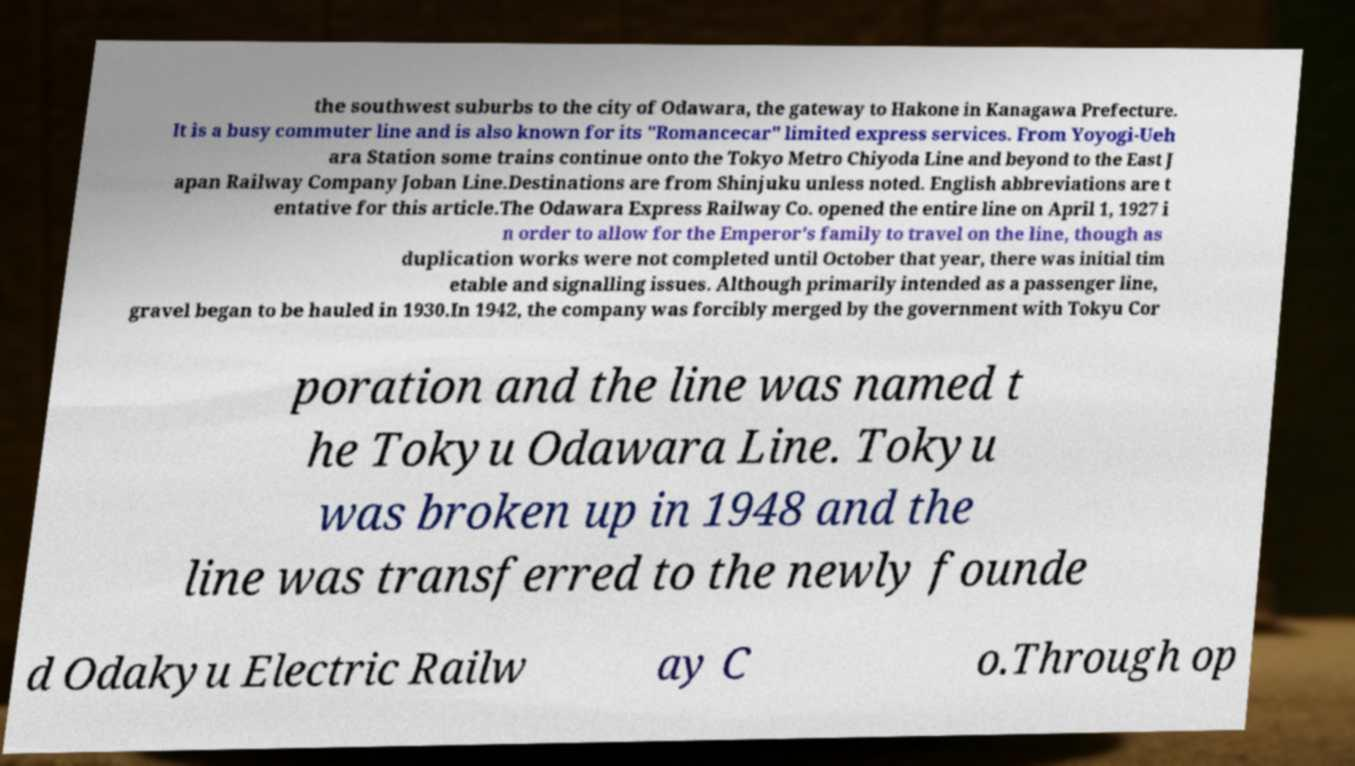I need the written content from this picture converted into text. Can you do that? the southwest suburbs to the city of Odawara, the gateway to Hakone in Kanagawa Prefecture. It is a busy commuter line and is also known for its "Romancecar" limited express services. From Yoyogi-Ueh ara Station some trains continue onto the Tokyo Metro Chiyoda Line and beyond to the East J apan Railway Company Joban Line.Destinations are from Shinjuku unless noted. English abbreviations are t entative for this article.The Odawara Express Railway Co. opened the entire line on April 1, 1927 i n order to allow for the Emperor's family to travel on the line, though as duplication works were not completed until October that year, there was initial tim etable and signalling issues. Although primarily intended as a passenger line, gravel began to be hauled in 1930.In 1942, the company was forcibly merged by the government with Tokyu Cor poration and the line was named t he Tokyu Odawara Line. Tokyu was broken up in 1948 and the line was transferred to the newly founde d Odakyu Electric Railw ay C o.Through op 